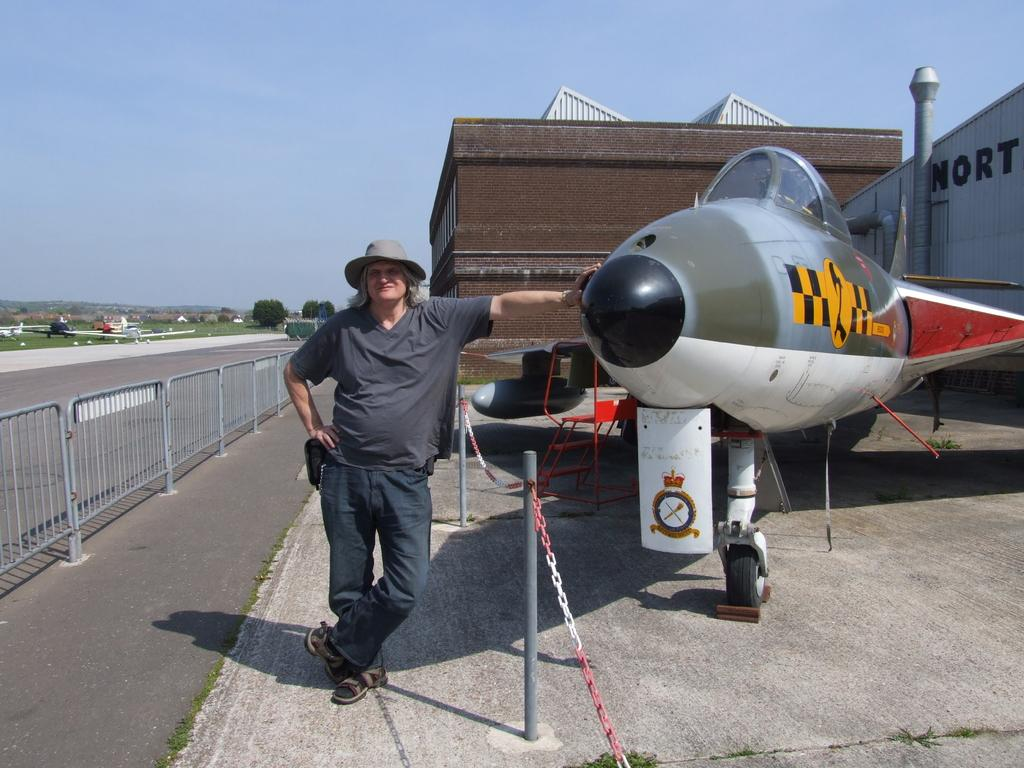<image>
Give a short and clear explanation of the subsequent image. An airplane is parked in front of a building whose name starts with NORT. 